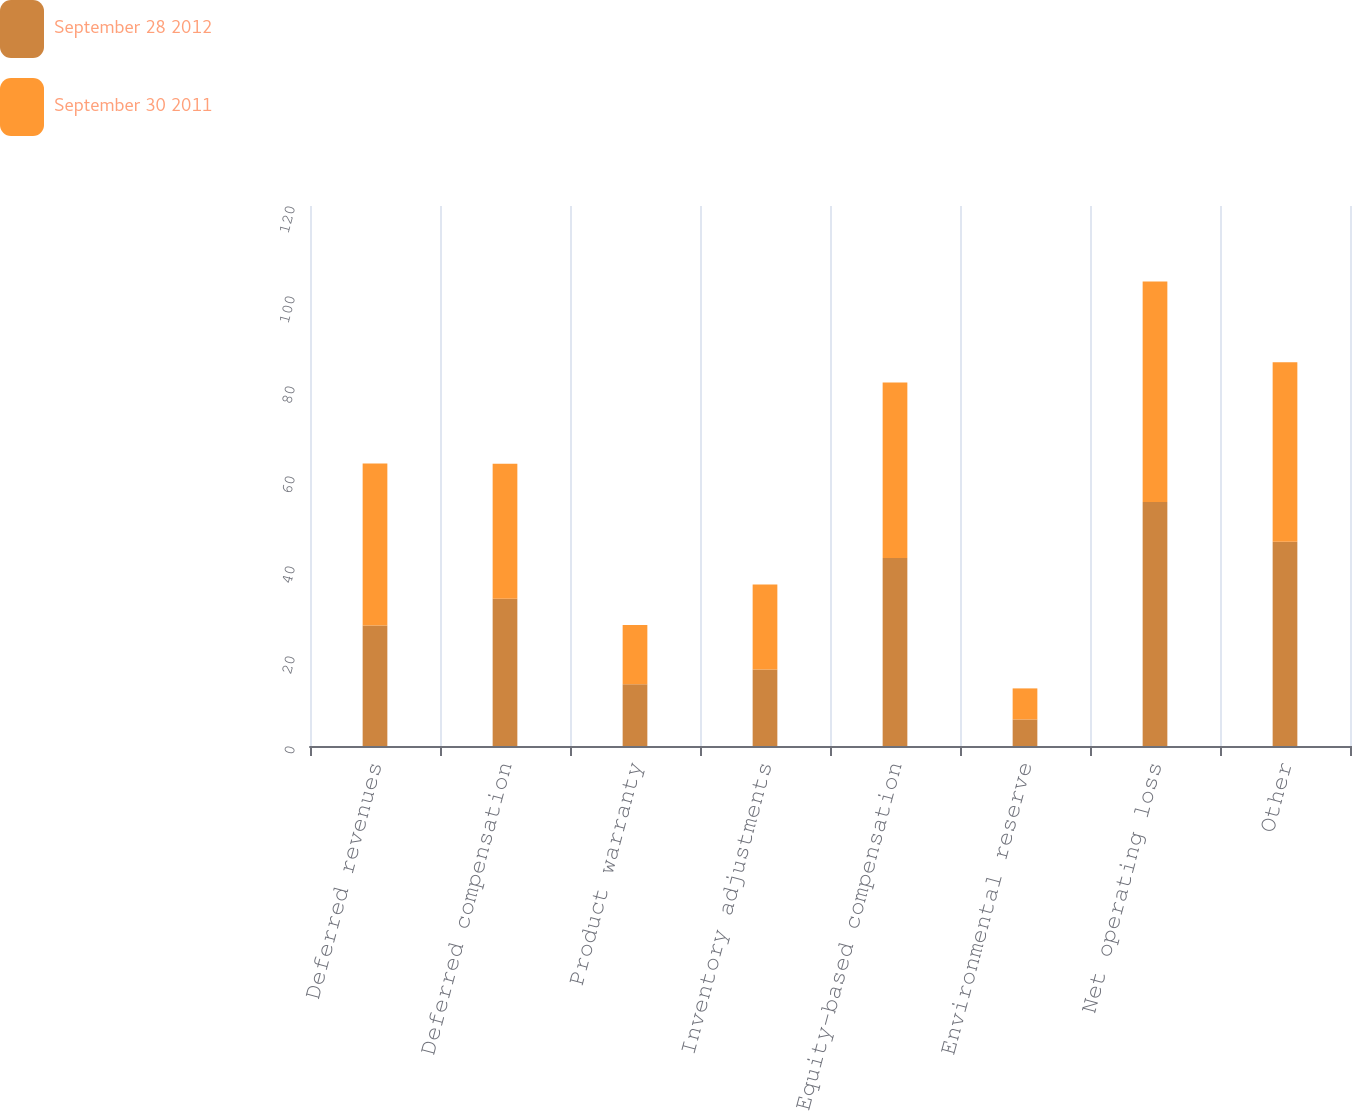<chart> <loc_0><loc_0><loc_500><loc_500><stacked_bar_chart><ecel><fcel>Deferred revenues<fcel>Deferred compensation<fcel>Product warranty<fcel>Inventory adjustments<fcel>Equity-based compensation<fcel>Environmental reserve<fcel>Net operating loss<fcel>Other<nl><fcel>September 28 2012<fcel>26.8<fcel>32.7<fcel>13.7<fcel>17<fcel>41.8<fcel>5.9<fcel>54.2<fcel>45.4<nl><fcel>September 30 2011<fcel>36<fcel>30<fcel>13.2<fcel>18.9<fcel>39<fcel>6.9<fcel>49<fcel>39.9<nl></chart> 